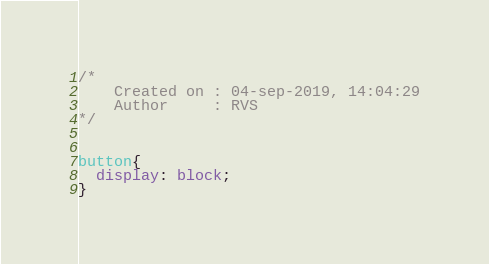Convert code to text. <code><loc_0><loc_0><loc_500><loc_500><_CSS_>/* 
    Created on : 04-sep-2019, 14:04:29
    Author     : RVS
*/


button{
  display: block;
}</code> 